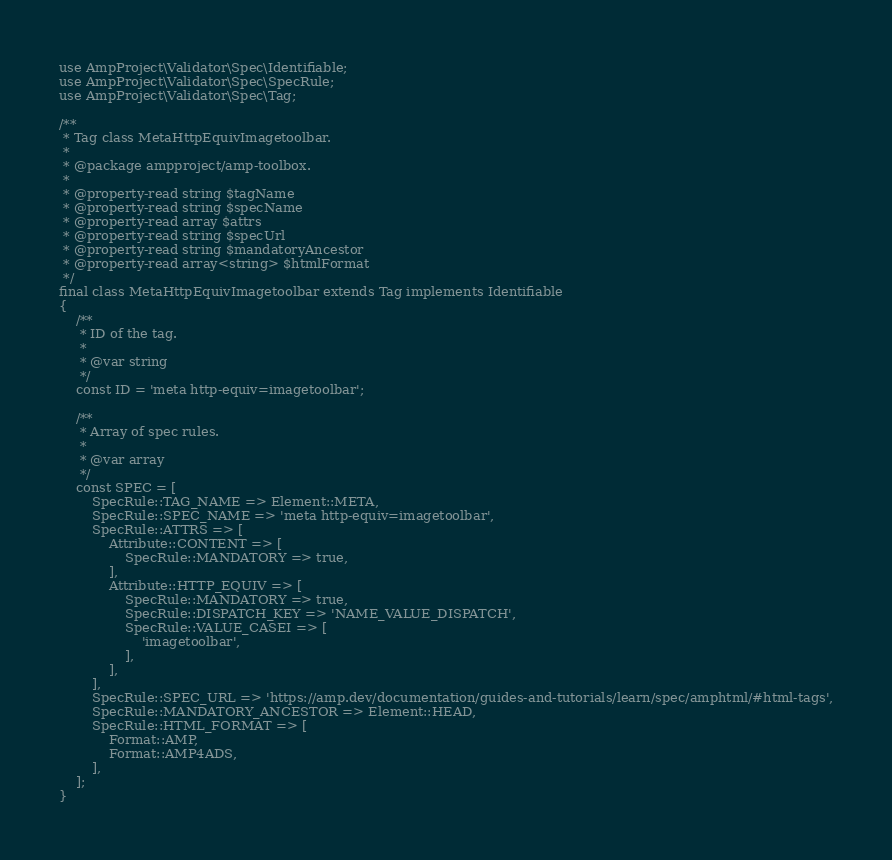Convert code to text. <code><loc_0><loc_0><loc_500><loc_500><_PHP_>use AmpProject\Validator\Spec\Identifiable;
use AmpProject\Validator\Spec\SpecRule;
use AmpProject\Validator\Spec\Tag;

/**
 * Tag class MetaHttpEquivImagetoolbar.
 *
 * @package ampproject/amp-toolbox.
 *
 * @property-read string $tagName
 * @property-read string $specName
 * @property-read array $attrs
 * @property-read string $specUrl
 * @property-read string $mandatoryAncestor
 * @property-read array<string> $htmlFormat
 */
final class MetaHttpEquivImagetoolbar extends Tag implements Identifiable
{
    /**
     * ID of the tag.
     *
     * @var string
     */
    const ID = 'meta http-equiv=imagetoolbar';

    /**
     * Array of spec rules.
     *
     * @var array
     */
    const SPEC = [
        SpecRule::TAG_NAME => Element::META,
        SpecRule::SPEC_NAME => 'meta http-equiv=imagetoolbar',
        SpecRule::ATTRS => [
            Attribute::CONTENT => [
                SpecRule::MANDATORY => true,
            ],
            Attribute::HTTP_EQUIV => [
                SpecRule::MANDATORY => true,
                SpecRule::DISPATCH_KEY => 'NAME_VALUE_DISPATCH',
                SpecRule::VALUE_CASEI => [
                    'imagetoolbar',
                ],
            ],
        ],
        SpecRule::SPEC_URL => 'https://amp.dev/documentation/guides-and-tutorials/learn/spec/amphtml/#html-tags',
        SpecRule::MANDATORY_ANCESTOR => Element::HEAD,
        SpecRule::HTML_FORMAT => [
            Format::AMP,
            Format::AMP4ADS,
        ],
    ];
}
</code> 